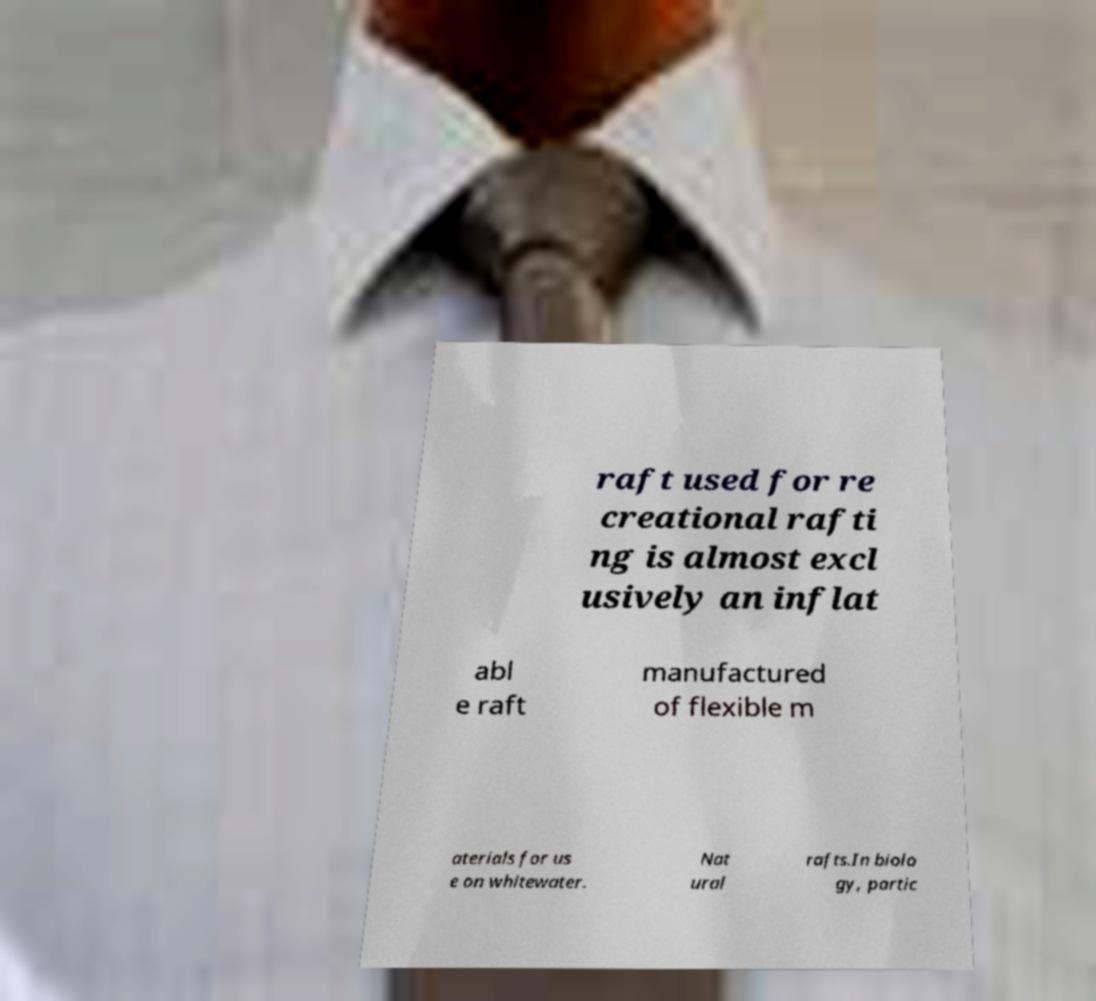There's text embedded in this image that I need extracted. Can you transcribe it verbatim? raft used for re creational rafti ng is almost excl usively an inflat abl e raft manufactured of flexible m aterials for us e on whitewater. Nat ural rafts.In biolo gy, partic 